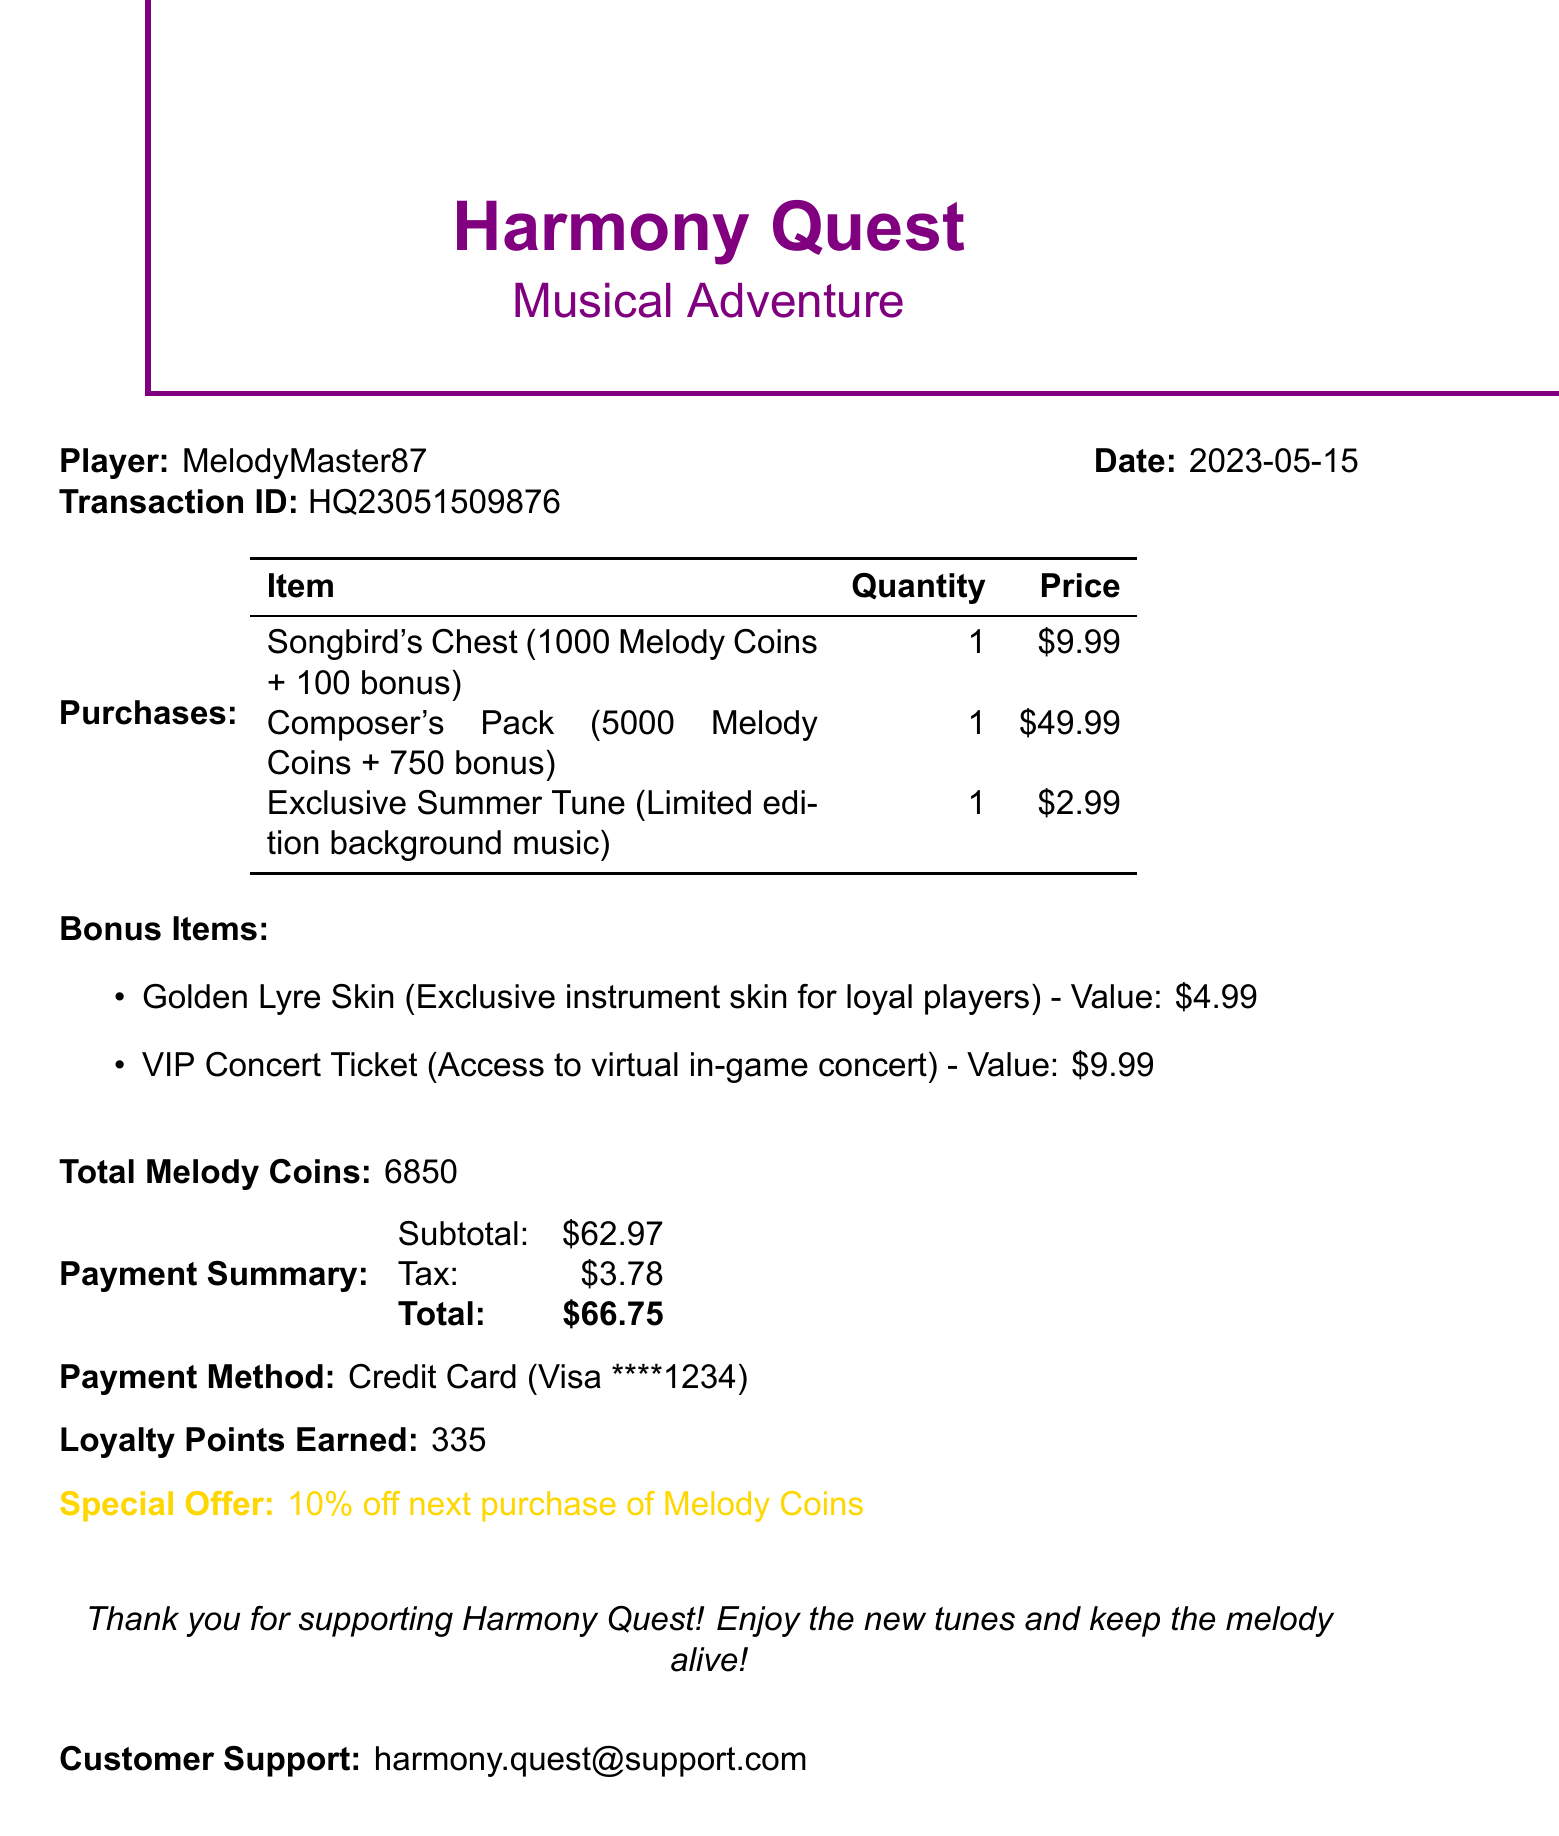What is the player's name? The player's name is listed at the top of the receipt under "Player:".
Answer: MelodyMaster87 What is the total amount spent? The total amount is shown in the payment summary as the total.
Answer: $66.75 How many Melody Coins were purchased in total? The total Melody Coins are explicitly mentioned in the document.
Answer: 6850 What bonus item is described as an exclusive instrument skin? The bonus items section lists the items, specifying which is the exclusive skin.
Answer: Golden Lyre Skin What is the date of the transaction? The transaction date is provided at the top of the receipt near the player's name.
Answer: 2023-05-15 What is the value of the VIP Concert Ticket? The value of the VIP Concert Ticket is included in the bonus items section.
Answer: $9.99 How many loyalty points were earned? The loyalty points earned are stated in a dedicated section of the receipt.
Answer: 335 What is the special offer provided to the player? The special offer is highlighted in a specific section of the document.
Answer: 10% off next purchase of Melody Coins What is the payment method used for the transaction? The payment method is detailed in the payment summary section of the receipt.
Answer: Credit Card (Visa ****1234) 